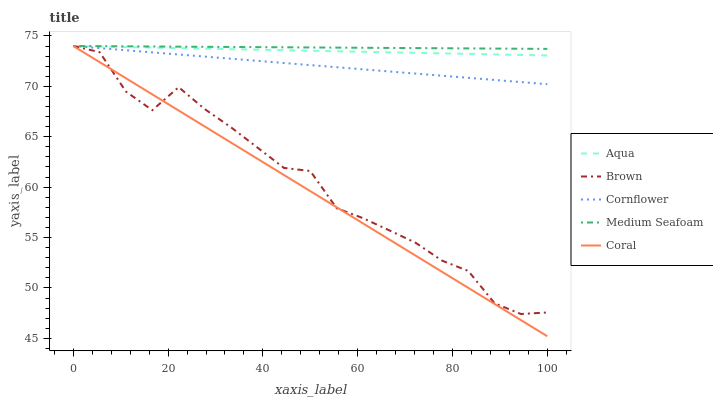Does Coral have the minimum area under the curve?
Answer yes or no. Yes. Does Medium Seafoam have the maximum area under the curve?
Answer yes or no. Yes. Does Aqua have the minimum area under the curve?
Answer yes or no. No. Does Aqua have the maximum area under the curve?
Answer yes or no. No. Is Cornflower the smoothest?
Answer yes or no. Yes. Is Brown the roughest?
Answer yes or no. Yes. Is Coral the smoothest?
Answer yes or no. No. Is Coral the roughest?
Answer yes or no. No. Does Coral have the lowest value?
Answer yes or no. Yes. Does Aqua have the lowest value?
Answer yes or no. No. Does Cornflower have the highest value?
Answer yes or no. Yes. Does Cornflower intersect Brown?
Answer yes or no. Yes. Is Cornflower less than Brown?
Answer yes or no. No. Is Cornflower greater than Brown?
Answer yes or no. No. 